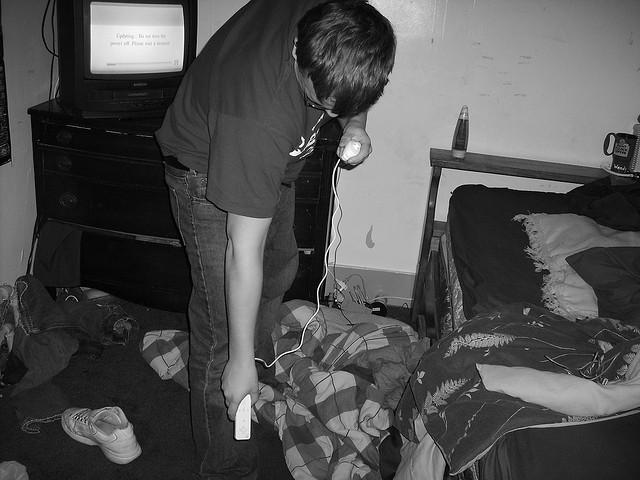What is the video game console connected to the television currently doing? Please explain your reasoning. updating. The video game console is currently updating. 